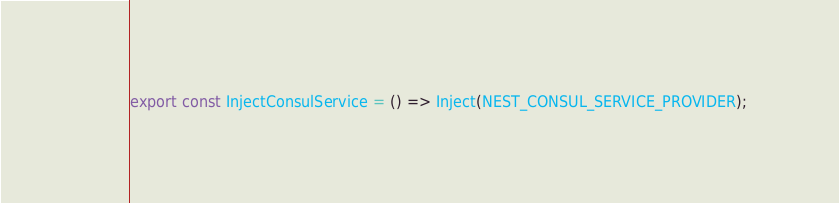Convert code to text. <code><loc_0><loc_0><loc_500><loc_500><_TypeScript_>export const InjectConsulService = () => Inject(NEST_CONSUL_SERVICE_PROVIDER);
</code> 